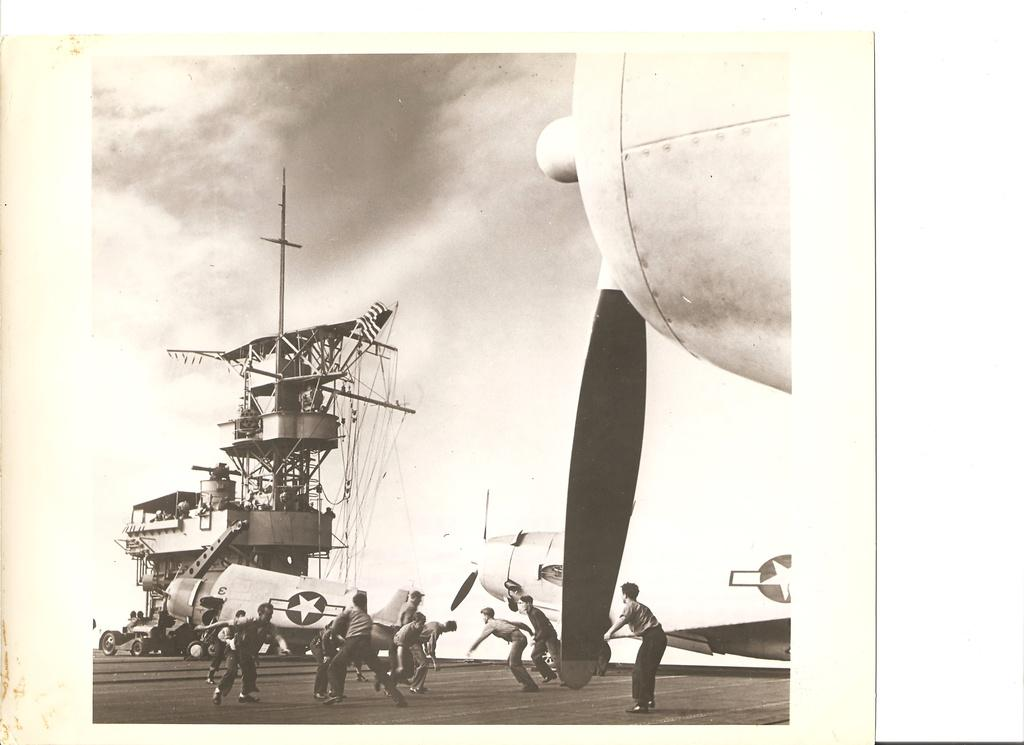What type of image is being described? The image is a photograph. Where are the people located in the image? The people are in the center of the image. What other subjects are present in the image besides people? There are aeroplanes and ships in the image. What can be seen in the background of the image? There is sky visible in the background of the image. What is the value of the cakes in the image? There are no cakes present in the image, so it is not possible to determine their value. 